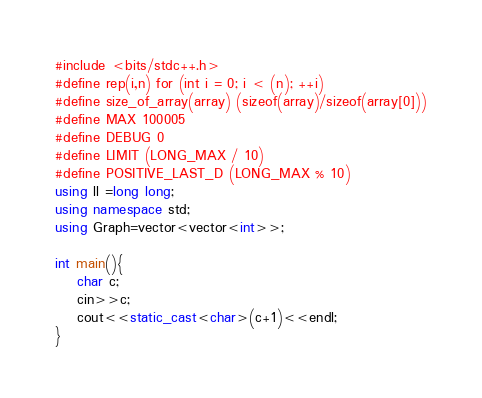Convert code to text. <code><loc_0><loc_0><loc_500><loc_500><_C++_>#include <bits/stdc++.h> 
#define rep(i,n) for (int i = 0; i < (n); ++i)
#define size_of_array(array) (sizeof(array)/sizeof(array[0]))
#define MAX 100005
#define DEBUG 0 
#define LIMIT (LONG_MAX / 10)
#define POSITIVE_LAST_D (LONG_MAX % 10)
using ll =long long;
using namespace std;
using Graph=vector<vector<int>>;

int main(){
    char c;
    cin>>c;
    cout<<static_cast<char>(c+1)<<endl;
}</code> 